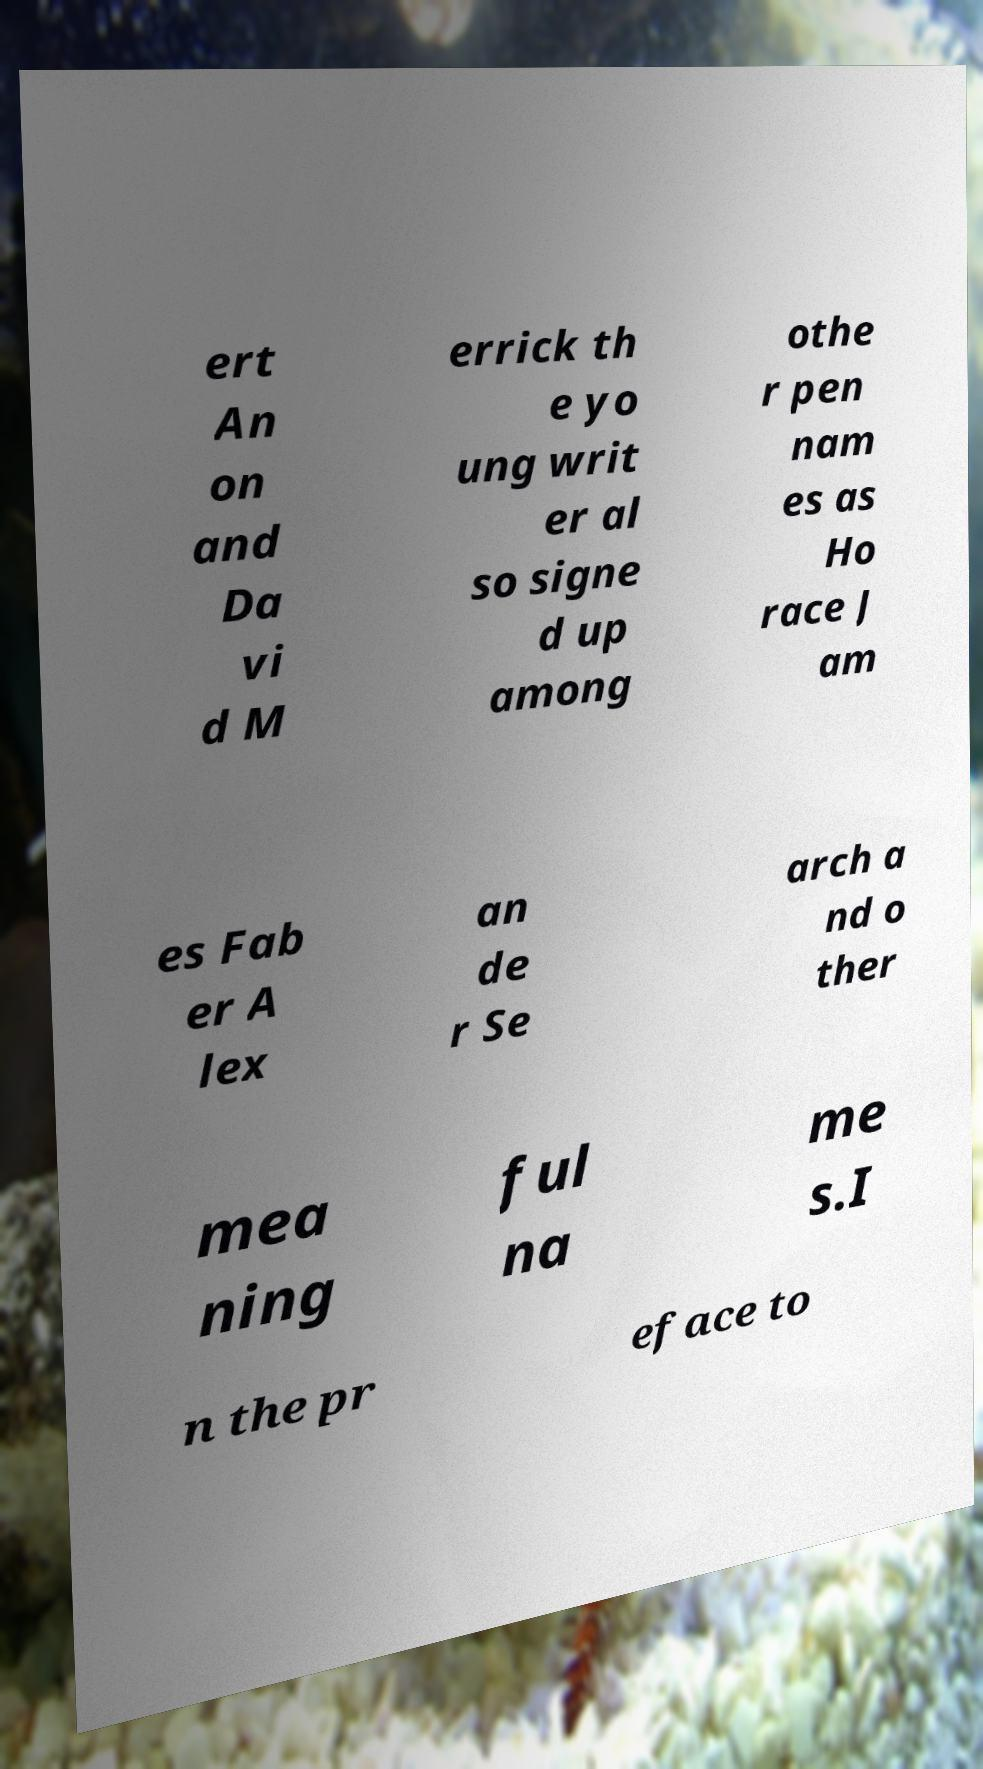I need the written content from this picture converted into text. Can you do that? ert An on and Da vi d M errick th e yo ung writ er al so signe d up among othe r pen nam es as Ho race J am es Fab er A lex an de r Se arch a nd o ther mea ning ful na me s.I n the pr eface to 